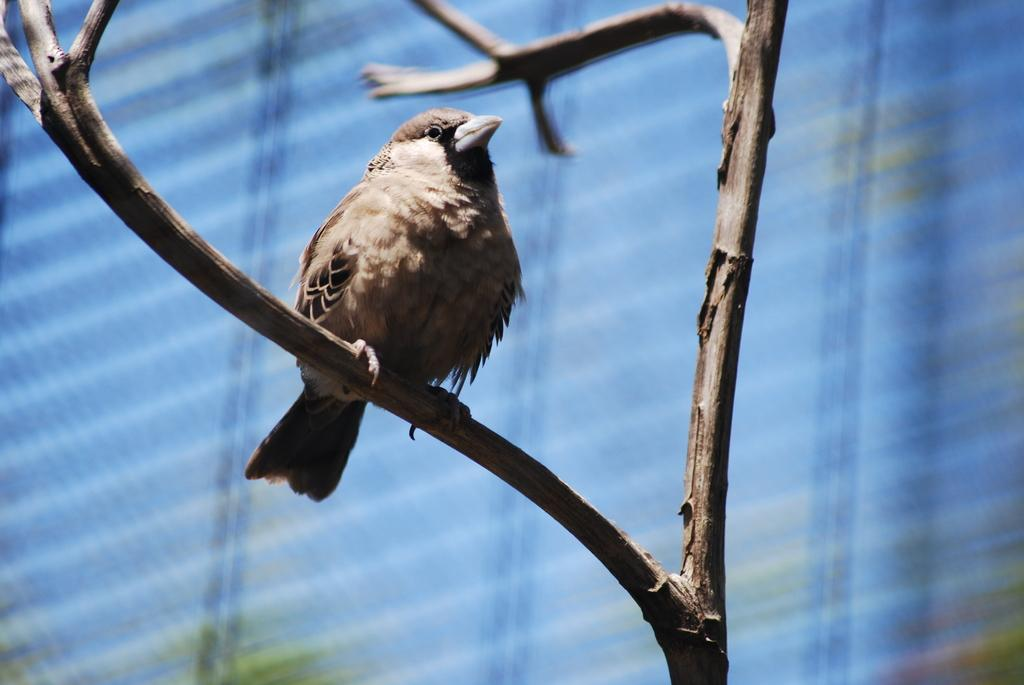What type of animal can be seen in the image? There is a bird in the image. Where is the bird located in the image? The bird is sitting on a tree branch. Can you describe the position of the bird in the image? The bird is in the center of the image. What color is the spark coming from the hydrant in the image? There is no spark or hydrant present in the image; it features a bird sitting on a tree branch. 